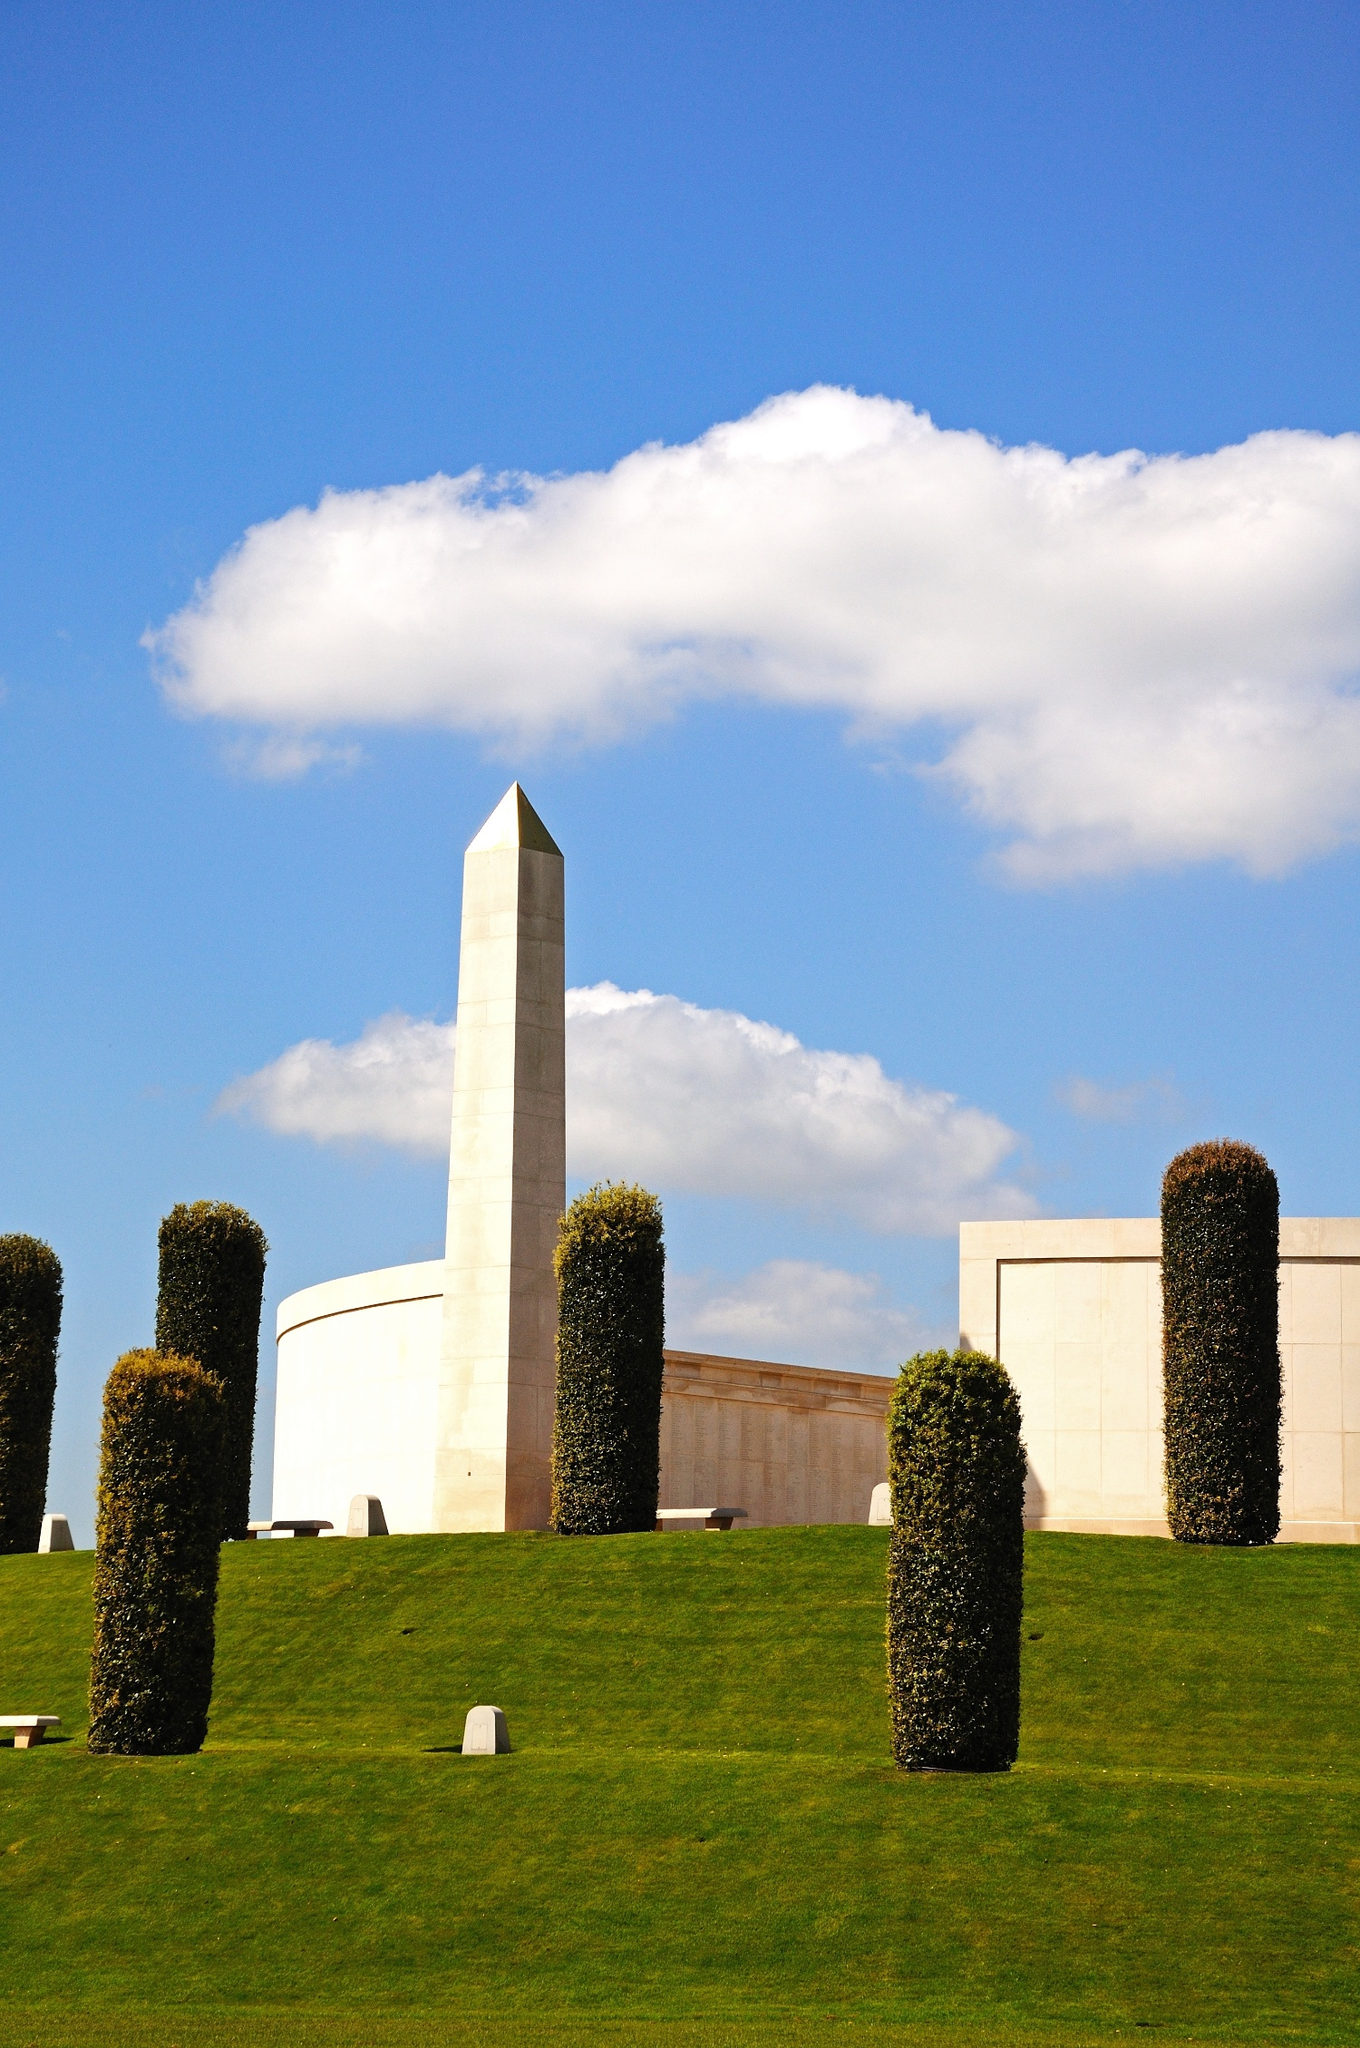If you could ask the obelisk one question, what would it be and what do you think the obelisk would reply? Human: Obelisk, having stood here for so long, what have you observed about the people who visit this place? 
Obelisk: I have witnessed countless moments of silent reflection and tearful remembrance. Visitors come with heavy hearts, seeking solace and understanding. They stand before me and the other memorials, expressing their gratitude and finding comfort in the collective remembrance of sacrifice and service. Through the changing seasons, I see the strength and unity that remembrance brings, encapsulating memories and emotions in a timeless embrace. 